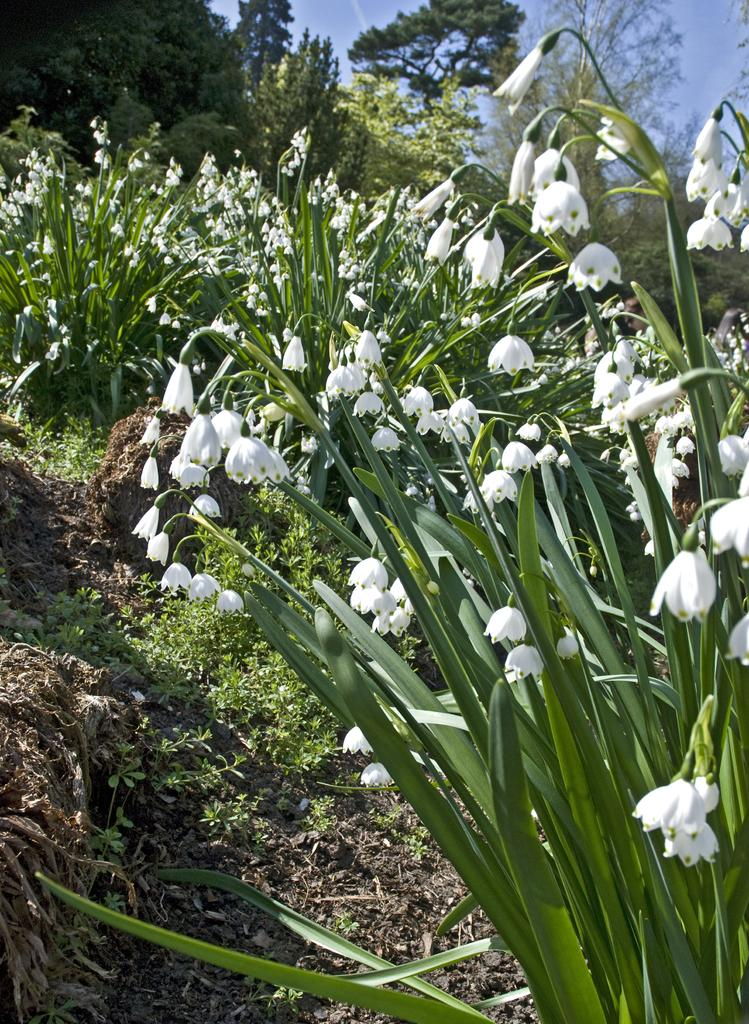What types of vegetation can be seen in the front of the image? There are plants and flowers in the front of the image. What can be seen in the background of the image? There are trees in the background of the image. What part of the sky is visible in the image? The sky is visible at the top right of the image. What type of advice can be seen being given in the image? There is no advice present in the image; it features plants, flowers, trees, and the sky. 